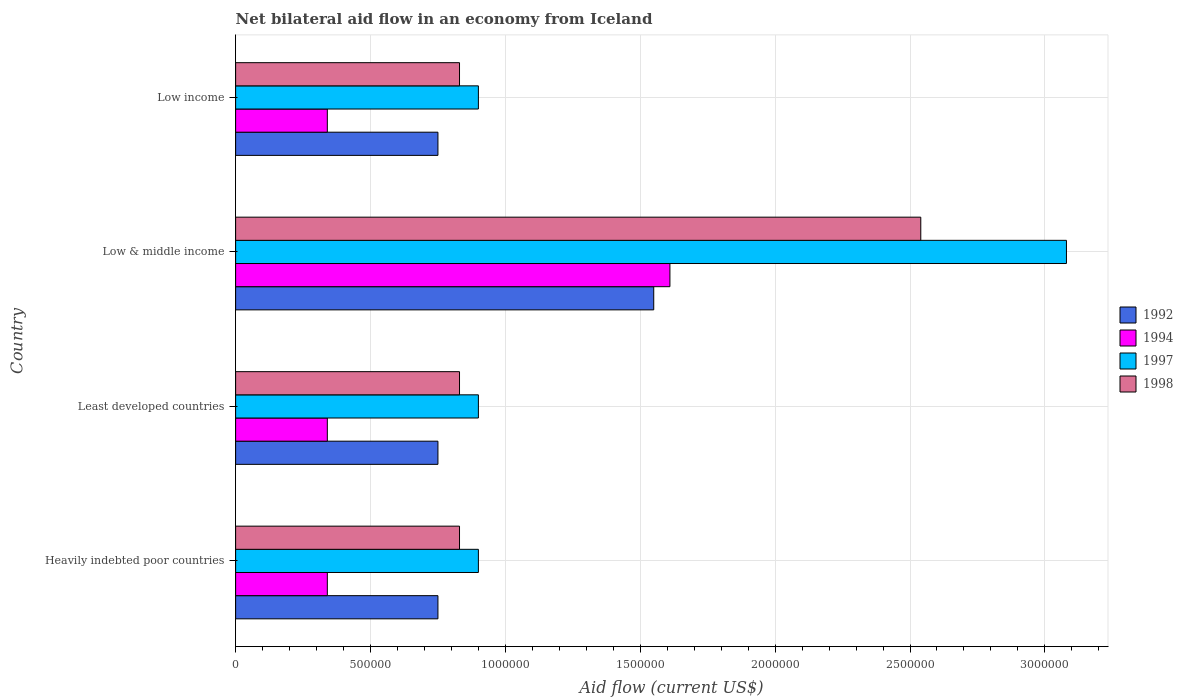How many different coloured bars are there?
Your response must be concise. 4. How many groups of bars are there?
Keep it short and to the point. 4. Are the number of bars per tick equal to the number of legend labels?
Offer a very short reply. Yes. Are the number of bars on each tick of the Y-axis equal?
Your answer should be very brief. Yes. How many bars are there on the 3rd tick from the bottom?
Ensure brevity in your answer.  4. What is the label of the 4th group of bars from the top?
Provide a short and direct response. Heavily indebted poor countries. In how many cases, is the number of bars for a given country not equal to the number of legend labels?
Your answer should be compact. 0. What is the net bilateral aid flow in 1998 in Low & middle income?
Your response must be concise. 2.54e+06. Across all countries, what is the maximum net bilateral aid flow in 1992?
Your response must be concise. 1.55e+06. Across all countries, what is the minimum net bilateral aid flow in 1992?
Provide a succinct answer. 7.50e+05. In which country was the net bilateral aid flow in 1997 minimum?
Make the answer very short. Heavily indebted poor countries. What is the total net bilateral aid flow in 1992 in the graph?
Offer a terse response. 3.80e+06. What is the difference between the net bilateral aid flow in 1997 in Least developed countries and that in Low & middle income?
Keep it short and to the point. -2.18e+06. What is the difference between the net bilateral aid flow in 1998 in Low income and the net bilateral aid flow in 1994 in Low & middle income?
Offer a very short reply. -7.80e+05. What is the average net bilateral aid flow in 1998 per country?
Your response must be concise. 1.26e+06. What is the difference between the net bilateral aid flow in 1994 and net bilateral aid flow in 1997 in Least developed countries?
Keep it short and to the point. -5.60e+05. What is the ratio of the net bilateral aid flow in 1997 in Heavily indebted poor countries to that in Low & middle income?
Keep it short and to the point. 0.29. Is the difference between the net bilateral aid flow in 1994 in Heavily indebted poor countries and Low income greater than the difference between the net bilateral aid flow in 1997 in Heavily indebted poor countries and Low income?
Keep it short and to the point. No. What is the difference between the highest and the second highest net bilateral aid flow in 1997?
Give a very brief answer. 2.18e+06. What is the difference between the highest and the lowest net bilateral aid flow in 1998?
Your answer should be very brief. 1.71e+06. Is it the case that in every country, the sum of the net bilateral aid flow in 1994 and net bilateral aid flow in 1992 is greater than the sum of net bilateral aid flow in 1997 and net bilateral aid flow in 1998?
Ensure brevity in your answer.  No. How many bars are there?
Provide a succinct answer. 16. What is the difference between two consecutive major ticks on the X-axis?
Make the answer very short. 5.00e+05. Does the graph contain any zero values?
Provide a succinct answer. No. Does the graph contain grids?
Give a very brief answer. Yes. Where does the legend appear in the graph?
Ensure brevity in your answer.  Center right. How many legend labels are there?
Provide a short and direct response. 4. How are the legend labels stacked?
Keep it short and to the point. Vertical. What is the title of the graph?
Provide a short and direct response. Net bilateral aid flow in an economy from Iceland. What is the label or title of the X-axis?
Your answer should be very brief. Aid flow (current US$). What is the label or title of the Y-axis?
Keep it short and to the point. Country. What is the Aid flow (current US$) of 1992 in Heavily indebted poor countries?
Provide a short and direct response. 7.50e+05. What is the Aid flow (current US$) in 1997 in Heavily indebted poor countries?
Your response must be concise. 9.00e+05. What is the Aid flow (current US$) in 1998 in Heavily indebted poor countries?
Provide a succinct answer. 8.30e+05. What is the Aid flow (current US$) of 1992 in Least developed countries?
Provide a short and direct response. 7.50e+05. What is the Aid flow (current US$) of 1997 in Least developed countries?
Ensure brevity in your answer.  9.00e+05. What is the Aid flow (current US$) of 1998 in Least developed countries?
Keep it short and to the point. 8.30e+05. What is the Aid flow (current US$) in 1992 in Low & middle income?
Offer a very short reply. 1.55e+06. What is the Aid flow (current US$) of 1994 in Low & middle income?
Offer a terse response. 1.61e+06. What is the Aid flow (current US$) of 1997 in Low & middle income?
Your response must be concise. 3.08e+06. What is the Aid flow (current US$) in 1998 in Low & middle income?
Your response must be concise. 2.54e+06. What is the Aid flow (current US$) in 1992 in Low income?
Make the answer very short. 7.50e+05. What is the Aid flow (current US$) of 1994 in Low income?
Offer a terse response. 3.40e+05. What is the Aid flow (current US$) of 1997 in Low income?
Give a very brief answer. 9.00e+05. What is the Aid flow (current US$) in 1998 in Low income?
Provide a short and direct response. 8.30e+05. Across all countries, what is the maximum Aid flow (current US$) of 1992?
Provide a succinct answer. 1.55e+06. Across all countries, what is the maximum Aid flow (current US$) of 1994?
Your answer should be compact. 1.61e+06. Across all countries, what is the maximum Aid flow (current US$) of 1997?
Your answer should be compact. 3.08e+06. Across all countries, what is the maximum Aid flow (current US$) of 1998?
Your response must be concise. 2.54e+06. Across all countries, what is the minimum Aid flow (current US$) in 1992?
Keep it short and to the point. 7.50e+05. Across all countries, what is the minimum Aid flow (current US$) of 1994?
Offer a terse response. 3.40e+05. Across all countries, what is the minimum Aid flow (current US$) in 1997?
Provide a short and direct response. 9.00e+05. Across all countries, what is the minimum Aid flow (current US$) of 1998?
Offer a very short reply. 8.30e+05. What is the total Aid flow (current US$) of 1992 in the graph?
Offer a terse response. 3.80e+06. What is the total Aid flow (current US$) in 1994 in the graph?
Make the answer very short. 2.63e+06. What is the total Aid flow (current US$) in 1997 in the graph?
Your response must be concise. 5.78e+06. What is the total Aid flow (current US$) of 1998 in the graph?
Provide a succinct answer. 5.03e+06. What is the difference between the Aid flow (current US$) of 1997 in Heavily indebted poor countries and that in Least developed countries?
Keep it short and to the point. 0. What is the difference between the Aid flow (current US$) in 1998 in Heavily indebted poor countries and that in Least developed countries?
Give a very brief answer. 0. What is the difference between the Aid flow (current US$) in 1992 in Heavily indebted poor countries and that in Low & middle income?
Provide a succinct answer. -8.00e+05. What is the difference between the Aid flow (current US$) of 1994 in Heavily indebted poor countries and that in Low & middle income?
Give a very brief answer. -1.27e+06. What is the difference between the Aid flow (current US$) in 1997 in Heavily indebted poor countries and that in Low & middle income?
Provide a succinct answer. -2.18e+06. What is the difference between the Aid flow (current US$) in 1998 in Heavily indebted poor countries and that in Low & middle income?
Make the answer very short. -1.71e+06. What is the difference between the Aid flow (current US$) of 1992 in Heavily indebted poor countries and that in Low income?
Provide a succinct answer. 0. What is the difference between the Aid flow (current US$) of 1997 in Heavily indebted poor countries and that in Low income?
Provide a short and direct response. 0. What is the difference between the Aid flow (current US$) of 1992 in Least developed countries and that in Low & middle income?
Your response must be concise. -8.00e+05. What is the difference between the Aid flow (current US$) in 1994 in Least developed countries and that in Low & middle income?
Your response must be concise. -1.27e+06. What is the difference between the Aid flow (current US$) in 1997 in Least developed countries and that in Low & middle income?
Make the answer very short. -2.18e+06. What is the difference between the Aid flow (current US$) in 1998 in Least developed countries and that in Low & middle income?
Provide a succinct answer. -1.71e+06. What is the difference between the Aid flow (current US$) of 1992 in Least developed countries and that in Low income?
Offer a very short reply. 0. What is the difference between the Aid flow (current US$) of 1994 in Least developed countries and that in Low income?
Your answer should be compact. 0. What is the difference between the Aid flow (current US$) of 1997 in Least developed countries and that in Low income?
Give a very brief answer. 0. What is the difference between the Aid flow (current US$) of 1992 in Low & middle income and that in Low income?
Give a very brief answer. 8.00e+05. What is the difference between the Aid flow (current US$) of 1994 in Low & middle income and that in Low income?
Make the answer very short. 1.27e+06. What is the difference between the Aid flow (current US$) of 1997 in Low & middle income and that in Low income?
Provide a succinct answer. 2.18e+06. What is the difference between the Aid flow (current US$) in 1998 in Low & middle income and that in Low income?
Offer a terse response. 1.71e+06. What is the difference between the Aid flow (current US$) of 1994 in Heavily indebted poor countries and the Aid flow (current US$) of 1997 in Least developed countries?
Offer a very short reply. -5.60e+05. What is the difference between the Aid flow (current US$) of 1994 in Heavily indebted poor countries and the Aid flow (current US$) of 1998 in Least developed countries?
Your answer should be compact. -4.90e+05. What is the difference between the Aid flow (current US$) of 1992 in Heavily indebted poor countries and the Aid flow (current US$) of 1994 in Low & middle income?
Keep it short and to the point. -8.60e+05. What is the difference between the Aid flow (current US$) in 1992 in Heavily indebted poor countries and the Aid flow (current US$) in 1997 in Low & middle income?
Offer a very short reply. -2.33e+06. What is the difference between the Aid flow (current US$) in 1992 in Heavily indebted poor countries and the Aid flow (current US$) in 1998 in Low & middle income?
Offer a terse response. -1.79e+06. What is the difference between the Aid flow (current US$) in 1994 in Heavily indebted poor countries and the Aid flow (current US$) in 1997 in Low & middle income?
Your answer should be very brief. -2.74e+06. What is the difference between the Aid flow (current US$) in 1994 in Heavily indebted poor countries and the Aid flow (current US$) in 1998 in Low & middle income?
Your answer should be compact. -2.20e+06. What is the difference between the Aid flow (current US$) of 1997 in Heavily indebted poor countries and the Aid flow (current US$) of 1998 in Low & middle income?
Your answer should be very brief. -1.64e+06. What is the difference between the Aid flow (current US$) of 1992 in Heavily indebted poor countries and the Aid flow (current US$) of 1994 in Low income?
Give a very brief answer. 4.10e+05. What is the difference between the Aid flow (current US$) of 1992 in Heavily indebted poor countries and the Aid flow (current US$) of 1997 in Low income?
Ensure brevity in your answer.  -1.50e+05. What is the difference between the Aid flow (current US$) in 1994 in Heavily indebted poor countries and the Aid flow (current US$) in 1997 in Low income?
Give a very brief answer. -5.60e+05. What is the difference between the Aid flow (current US$) of 1994 in Heavily indebted poor countries and the Aid flow (current US$) of 1998 in Low income?
Your answer should be very brief. -4.90e+05. What is the difference between the Aid flow (current US$) of 1992 in Least developed countries and the Aid flow (current US$) of 1994 in Low & middle income?
Give a very brief answer. -8.60e+05. What is the difference between the Aid flow (current US$) in 1992 in Least developed countries and the Aid flow (current US$) in 1997 in Low & middle income?
Make the answer very short. -2.33e+06. What is the difference between the Aid flow (current US$) of 1992 in Least developed countries and the Aid flow (current US$) of 1998 in Low & middle income?
Give a very brief answer. -1.79e+06. What is the difference between the Aid flow (current US$) of 1994 in Least developed countries and the Aid flow (current US$) of 1997 in Low & middle income?
Provide a succinct answer. -2.74e+06. What is the difference between the Aid flow (current US$) in 1994 in Least developed countries and the Aid flow (current US$) in 1998 in Low & middle income?
Provide a short and direct response. -2.20e+06. What is the difference between the Aid flow (current US$) of 1997 in Least developed countries and the Aid flow (current US$) of 1998 in Low & middle income?
Your answer should be very brief. -1.64e+06. What is the difference between the Aid flow (current US$) in 1992 in Least developed countries and the Aid flow (current US$) in 1994 in Low income?
Offer a terse response. 4.10e+05. What is the difference between the Aid flow (current US$) of 1992 in Least developed countries and the Aid flow (current US$) of 1997 in Low income?
Offer a very short reply. -1.50e+05. What is the difference between the Aid flow (current US$) in 1992 in Least developed countries and the Aid flow (current US$) in 1998 in Low income?
Keep it short and to the point. -8.00e+04. What is the difference between the Aid flow (current US$) in 1994 in Least developed countries and the Aid flow (current US$) in 1997 in Low income?
Your answer should be very brief. -5.60e+05. What is the difference between the Aid flow (current US$) of 1994 in Least developed countries and the Aid flow (current US$) of 1998 in Low income?
Your response must be concise. -4.90e+05. What is the difference between the Aid flow (current US$) in 1997 in Least developed countries and the Aid flow (current US$) in 1998 in Low income?
Your answer should be very brief. 7.00e+04. What is the difference between the Aid flow (current US$) in 1992 in Low & middle income and the Aid flow (current US$) in 1994 in Low income?
Your answer should be very brief. 1.21e+06. What is the difference between the Aid flow (current US$) in 1992 in Low & middle income and the Aid flow (current US$) in 1997 in Low income?
Offer a terse response. 6.50e+05. What is the difference between the Aid flow (current US$) of 1992 in Low & middle income and the Aid flow (current US$) of 1998 in Low income?
Your answer should be very brief. 7.20e+05. What is the difference between the Aid flow (current US$) of 1994 in Low & middle income and the Aid flow (current US$) of 1997 in Low income?
Give a very brief answer. 7.10e+05. What is the difference between the Aid flow (current US$) in 1994 in Low & middle income and the Aid flow (current US$) in 1998 in Low income?
Keep it short and to the point. 7.80e+05. What is the difference between the Aid flow (current US$) in 1997 in Low & middle income and the Aid flow (current US$) in 1998 in Low income?
Offer a terse response. 2.25e+06. What is the average Aid flow (current US$) in 1992 per country?
Your answer should be compact. 9.50e+05. What is the average Aid flow (current US$) of 1994 per country?
Offer a very short reply. 6.58e+05. What is the average Aid flow (current US$) in 1997 per country?
Ensure brevity in your answer.  1.44e+06. What is the average Aid flow (current US$) of 1998 per country?
Your answer should be very brief. 1.26e+06. What is the difference between the Aid flow (current US$) in 1992 and Aid flow (current US$) in 1994 in Heavily indebted poor countries?
Your response must be concise. 4.10e+05. What is the difference between the Aid flow (current US$) in 1992 and Aid flow (current US$) in 1997 in Heavily indebted poor countries?
Make the answer very short. -1.50e+05. What is the difference between the Aid flow (current US$) in 1994 and Aid flow (current US$) in 1997 in Heavily indebted poor countries?
Ensure brevity in your answer.  -5.60e+05. What is the difference between the Aid flow (current US$) in 1994 and Aid flow (current US$) in 1998 in Heavily indebted poor countries?
Provide a succinct answer. -4.90e+05. What is the difference between the Aid flow (current US$) in 1997 and Aid flow (current US$) in 1998 in Heavily indebted poor countries?
Offer a terse response. 7.00e+04. What is the difference between the Aid flow (current US$) in 1992 and Aid flow (current US$) in 1998 in Least developed countries?
Keep it short and to the point. -8.00e+04. What is the difference between the Aid flow (current US$) in 1994 and Aid flow (current US$) in 1997 in Least developed countries?
Provide a short and direct response. -5.60e+05. What is the difference between the Aid flow (current US$) of 1994 and Aid flow (current US$) of 1998 in Least developed countries?
Your answer should be very brief. -4.90e+05. What is the difference between the Aid flow (current US$) in 1997 and Aid flow (current US$) in 1998 in Least developed countries?
Ensure brevity in your answer.  7.00e+04. What is the difference between the Aid flow (current US$) of 1992 and Aid flow (current US$) of 1997 in Low & middle income?
Your answer should be very brief. -1.53e+06. What is the difference between the Aid flow (current US$) in 1992 and Aid flow (current US$) in 1998 in Low & middle income?
Provide a short and direct response. -9.90e+05. What is the difference between the Aid flow (current US$) in 1994 and Aid flow (current US$) in 1997 in Low & middle income?
Offer a very short reply. -1.47e+06. What is the difference between the Aid flow (current US$) in 1994 and Aid flow (current US$) in 1998 in Low & middle income?
Ensure brevity in your answer.  -9.30e+05. What is the difference between the Aid flow (current US$) in 1997 and Aid flow (current US$) in 1998 in Low & middle income?
Your answer should be very brief. 5.40e+05. What is the difference between the Aid flow (current US$) in 1992 and Aid flow (current US$) in 1994 in Low income?
Provide a short and direct response. 4.10e+05. What is the difference between the Aid flow (current US$) in 1992 and Aid flow (current US$) in 1998 in Low income?
Make the answer very short. -8.00e+04. What is the difference between the Aid flow (current US$) of 1994 and Aid flow (current US$) of 1997 in Low income?
Make the answer very short. -5.60e+05. What is the difference between the Aid flow (current US$) in 1994 and Aid flow (current US$) in 1998 in Low income?
Give a very brief answer. -4.90e+05. What is the ratio of the Aid flow (current US$) of 1994 in Heavily indebted poor countries to that in Least developed countries?
Make the answer very short. 1. What is the ratio of the Aid flow (current US$) in 1997 in Heavily indebted poor countries to that in Least developed countries?
Make the answer very short. 1. What is the ratio of the Aid flow (current US$) in 1992 in Heavily indebted poor countries to that in Low & middle income?
Offer a very short reply. 0.48. What is the ratio of the Aid flow (current US$) in 1994 in Heavily indebted poor countries to that in Low & middle income?
Give a very brief answer. 0.21. What is the ratio of the Aid flow (current US$) in 1997 in Heavily indebted poor countries to that in Low & middle income?
Provide a succinct answer. 0.29. What is the ratio of the Aid flow (current US$) of 1998 in Heavily indebted poor countries to that in Low & middle income?
Ensure brevity in your answer.  0.33. What is the ratio of the Aid flow (current US$) in 1992 in Heavily indebted poor countries to that in Low income?
Make the answer very short. 1. What is the ratio of the Aid flow (current US$) of 1997 in Heavily indebted poor countries to that in Low income?
Ensure brevity in your answer.  1. What is the ratio of the Aid flow (current US$) of 1998 in Heavily indebted poor countries to that in Low income?
Your answer should be compact. 1. What is the ratio of the Aid flow (current US$) in 1992 in Least developed countries to that in Low & middle income?
Make the answer very short. 0.48. What is the ratio of the Aid flow (current US$) in 1994 in Least developed countries to that in Low & middle income?
Provide a succinct answer. 0.21. What is the ratio of the Aid flow (current US$) of 1997 in Least developed countries to that in Low & middle income?
Provide a succinct answer. 0.29. What is the ratio of the Aid flow (current US$) in 1998 in Least developed countries to that in Low & middle income?
Keep it short and to the point. 0.33. What is the ratio of the Aid flow (current US$) in 1992 in Least developed countries to that in Low income?
Your answer should be compact. 1. What is the ratio of the Aid flow (current US$) in 1992 in Low & middle income to that in Low income?
Provide a short and direct response. 2.07. What is the ratio of the Aid flow (current US$) of 1994 in Low & middle income to that in Low income?
Your answer should be compact. 4.74. What is the ratio of the Aid flow (current US$) of 1997 in Low & middle income to that in Low income?
Offer a very short reply. 3.42. What is the ratio of the Aid flow (current US$) of 1998 in Low & middle income to that in Low income?
Offer a terse response. 3.06. What is the difference between the highest and the second highest Aid flow (current US$) of 1992?
Ensure brevity in your answer.  8.00e+05. What is the difference between the highest and the second highest Aid flow (current US$) in 1994?
Offer a terse response. 1.27e+06. What is the difference between the highest and the second highest Aid flow (current US$) of 1997?
Give a very brief answer. 2.18e+06. What is the difference between the highest and the second highest Aid flow (current US$) in 1998?
Make the answer very short. 1.71e+06. What is the difference between the highest and the lowest Aid flow (current US$) in 1994?
Offer a terse response. 1.27e+06. What is the difference between the highest and the lowest Aid flow (current US$) of 1997?
Your answer should be very brief. 2.18e+06. What is the difference between the highest and the lowest Aid flow (current US$) of 1998?
Offer a terse response. 1.71e+06. 